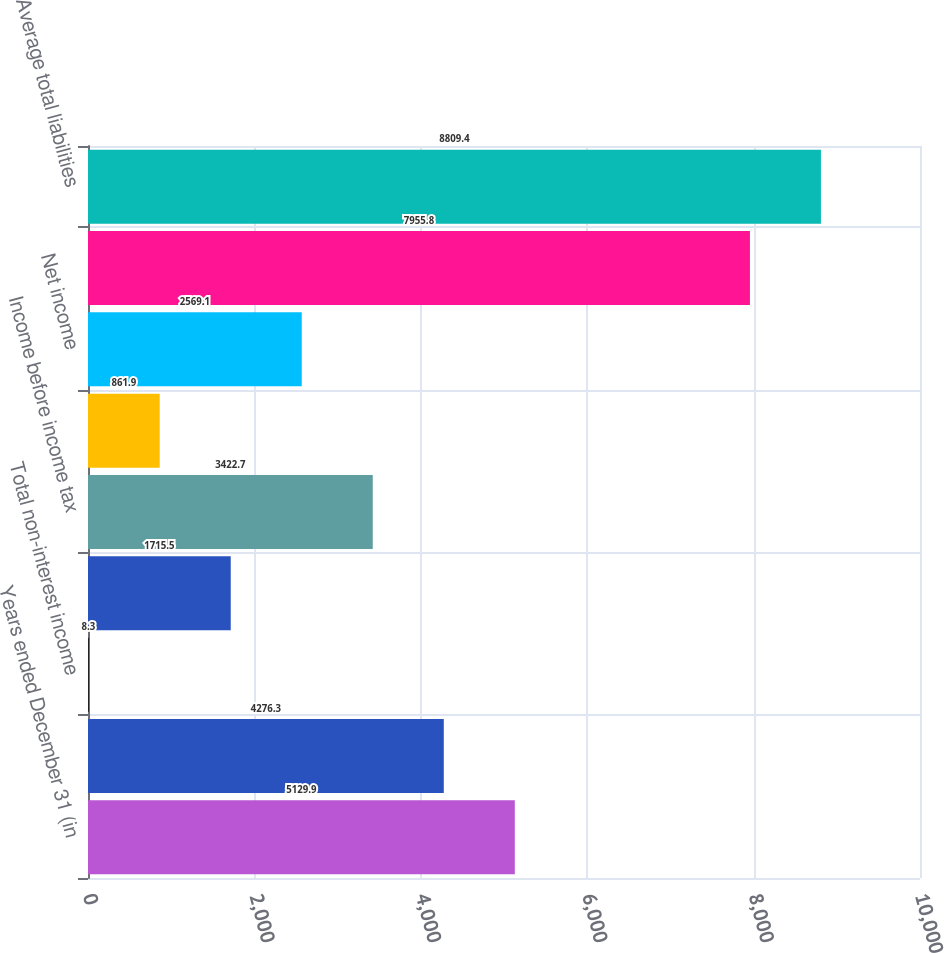<chart> <loc_0><loc_0><loc_500><loc_500><bar_chart><fcel>Years ended December 31 (in<fcel>Net interest income<fcel>Total non-interest income<fcel>Total non-interest expense<fcel>Income before income tax<fcel>Income tax expense<fcel>Net income<fcel>Average total assets<fcel>Average total liabilities<nl><fcel>5129.9<fcel>4276.3<fcel>8.3<fcel>1715.5<fcel>3422.7<fcel>861.9<fcel>2569.1<fcel>7955.8<fcel>8809.4<nl></chart> 